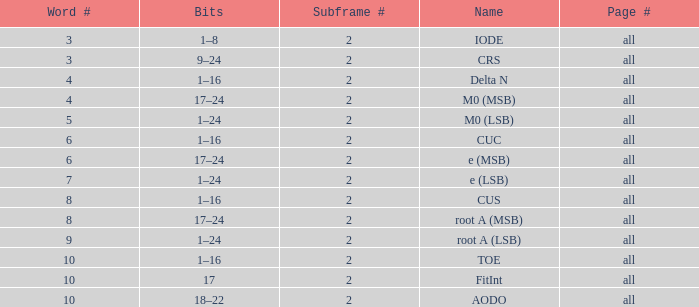What is the total subframe count with Bits of 18–22? 2.0. 